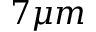Convert formula to latex. <formula><loc_0><loc_0><loc_500><loc_500>7 \mu m</formula> 